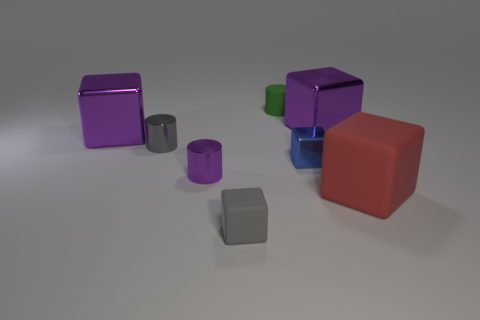Subtract all gray cubes. How many cubes are left? 4 Subtract all small metallic cubes. How many cubes are left? 4 Subtract 2 blocks. How many blocks are left? 3 Subtract all red cubes. Subtract all purple cylinders. How many cubes are left? 4 Add 2 blue metal blocks. How many objects exist? 10 Subtract all cylinders. How many objects are left? 5 Subtract 0 green balls. How many objects are left? 8 Subtract all big brown matte objects. Subtract all tiny green rubber things. How many objects are left? 7 Add 8 small purple cylinders. How many small purple cylinders are left? 9 Add 4 big gray shiny cylinders. How many big gray shiny cylinders exist? 4 